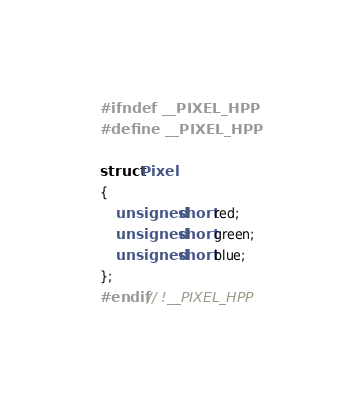Convert code to text. <code><loc_0><loc_0><loc_500><loc_500><_C++_>#ifndef __PIXEL_HPP
#define __PIXEL_HPP

struct Pixel
{
	unsigned short red;
	unsigned short green;
	unsigned short blue;
};
#endif // !__PIXEL_HPP
</code> 